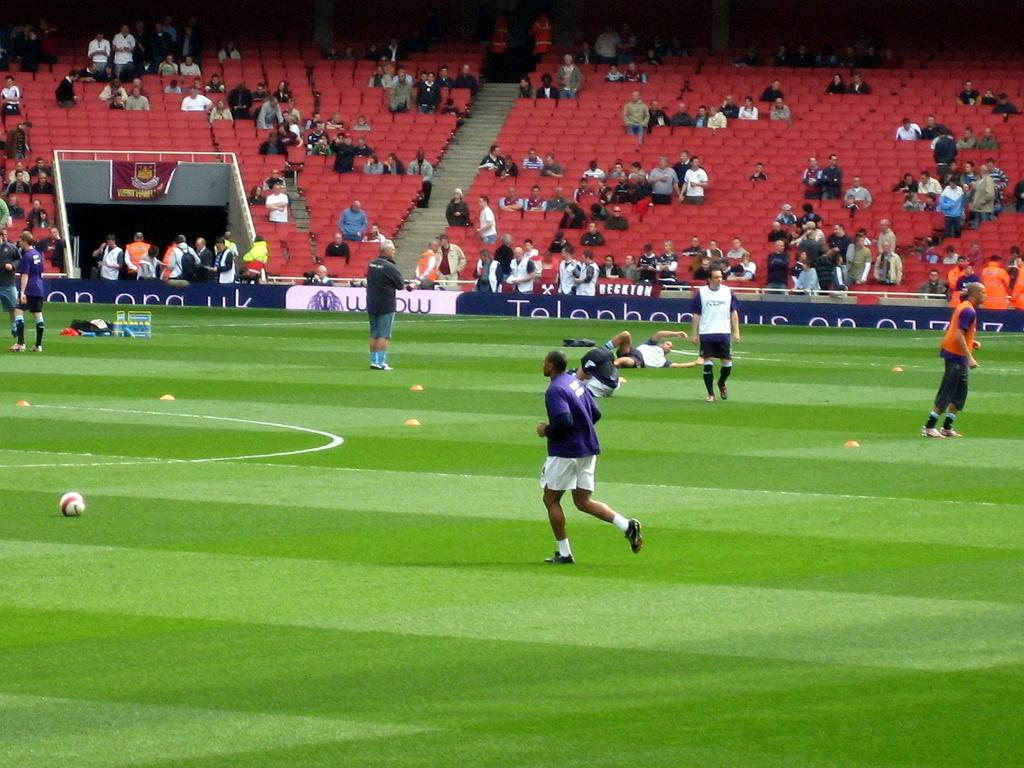What type of venue is depicted in the image? The image is of a stadium. What type of seating is available in the stadium? There are chairs in the image. Are there any architectural features visible in the image? Yes, there are steps in the image. Can you describe the people in the image? There are people in the image. What type of advertisement is present in the stadium? There is a hoarding in the image. What is on the grass in the image? There is a ball on the grass in the image. What is visible in the distance in the image? There are things far away in the image. What type of signage is present in the image? There is a banner in the image. What type of noise can be heard coming from the substance in the image? There is no substance present in the image, and therefore no noise can be heard from it. 